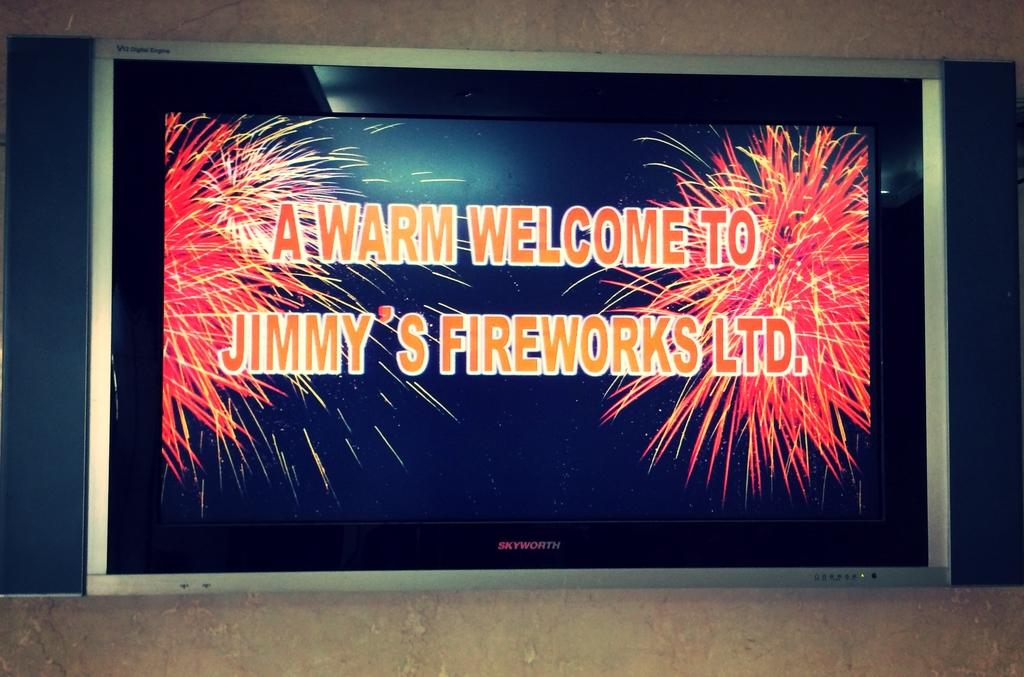<image>
Offer a succinct explanation of the picture presented. A screen displays a picture that states "A Warm Welcome to Jimmy's Fireworks Ltd." 